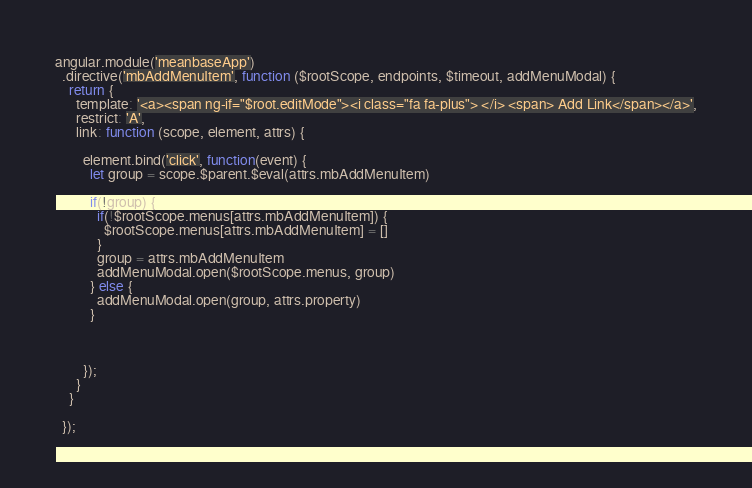Convert code to text. <code><loc_0><loc_0><loc_500><loc_500><_JavaScript_>angular.module('meanbaseApp')
  .directive('mbAddMenuItem', function ($rootScope, endpoints, $timeout, addMenuModal) {
    return {
      template: '<a><span ng-if="$root.editMode"><i class="fa fa-plus"> </i> <span> Add Link</span></a>',
      restrict: 'A',
      link: function (scope, element, attrs) {

        element.bind('click', function(event) {
          let group = scope.$parent.$eval(attrs.mbAddMenuItem)

          if(!group) {
            if(!$rootScope.menus[attrs.mbAddMenuItem]) {
              $rootScope.menus[attrs.mbAddMenuItem] = []
            }
            group = attrs.mbAddMenuItem
            addMenuModal.open($rootScope.menus, group)
          } else {
            addMenuModal.open(group, attrs.property)
          }



        });
      }
    }

  });
</code> 